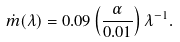Convert formula to latex. <formula><loc_0><loc_0><loc_500><loc_500>\dot { m } ( \lambda ) = 0 . 0 9 \left ( \frac { \alpha } { 0 . 0 1 } \right ) \lambda ^ { - 1 } .</formula> 